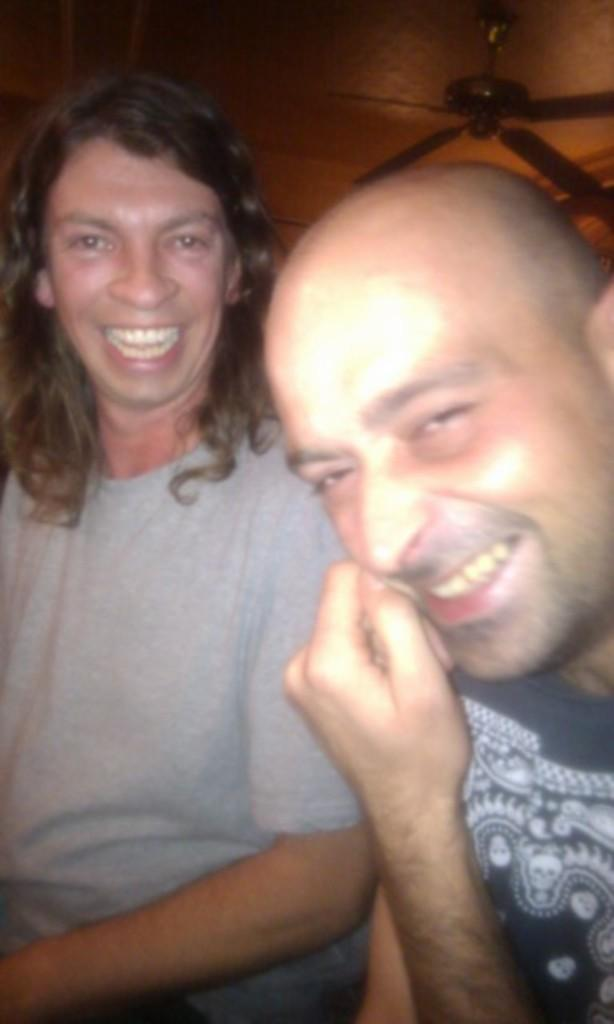How many people are in the image? There are two men in the image. What is the facial expression of the men in the image? The men are smiling in the image. What are the men looking at? The men are looking at something, but it is not specified in the facts. What architectural feature is visible in the image? There is a roof visible in the image. What is attached to the roof? There is a ceiling fan on the roof. Can you see a zebra flying in the image? No, there is no zebra or any flying object present in the image. 